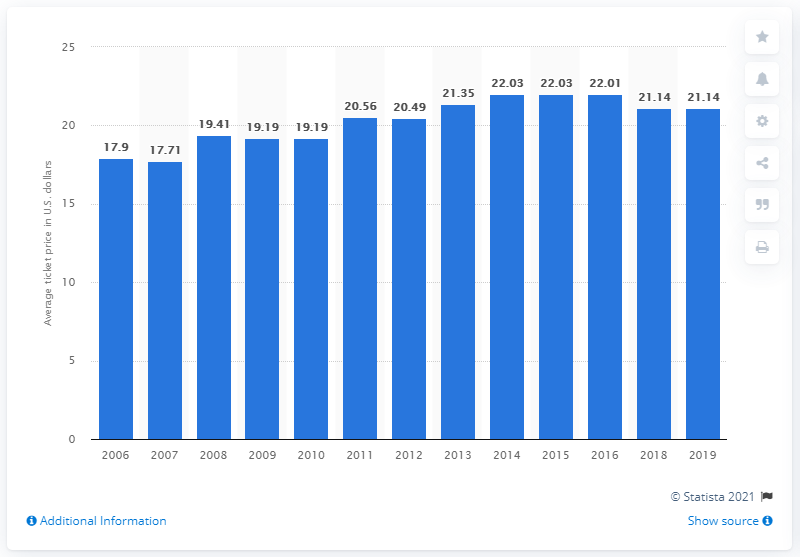Mention a couple of crucial points in this snapshot. In 2019, the average ticket price for Cincinnati Reds games was $21.14. 